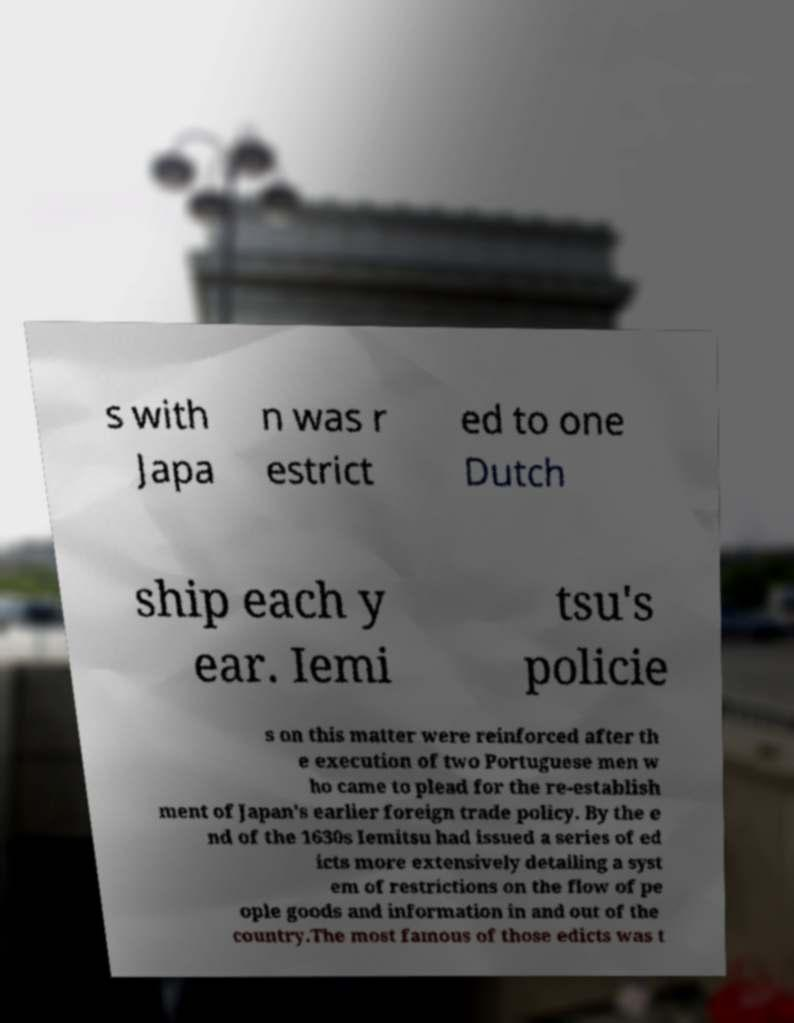Could you assist in decoding the text presented in this image and type it out clearly? s with Japa n was r estrict ed to one Dutch ship each y ear. Iemi tsu's policie s on this matter were reinforced after th e execution of two Portuguese men w ho came to plead for the re-establish ment of Japan's earlier foreign trade policy. By the e nd of the 1630s Iemitsu had issued a series of ed icts more extensively detailing a syst em of restrictions on the flow of pe ople goods and information in and out of the country.The most famous of those edicts was t 